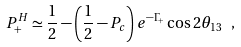Convert formula to latex. <formula><loc_0><loc_0><loc_500><loc_500>P _ { + } ^ { H } \simeq \frac { 1 } { 2 } - \left ( \frac { 1 } { 2 } - P _ { c } \right ) e ^ { - \Gamma _ { + } } \cos 2 \theta _ { 1 3 } \, \ ,</formula> 